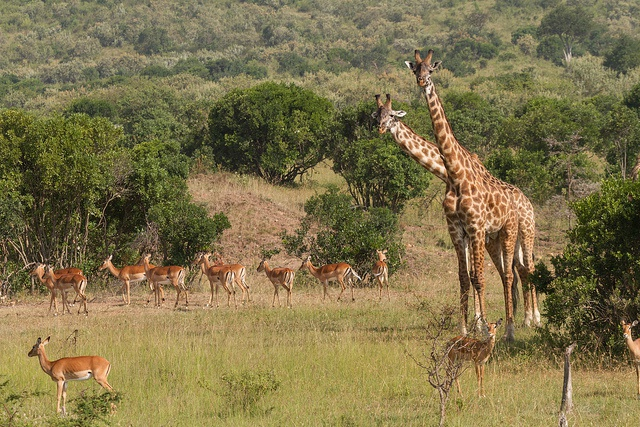Describe the objects in this image and their specific colors. I can see giraffe in olive, tan, gray, and maroon tones and giraffe in olive, gray, and tan tones in this image. 